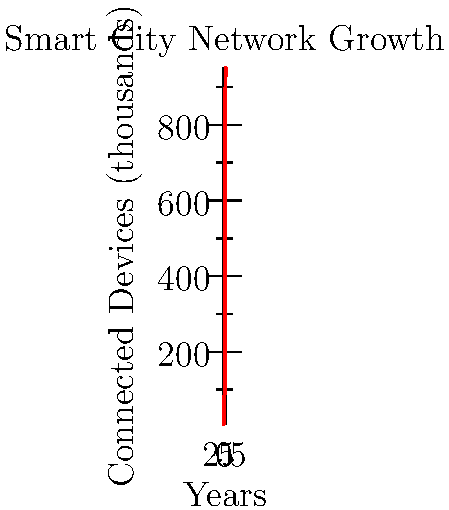In a smart city project, the number of connected devices is growing exponentially, as shown in the graph. If the current network infrastructure can support up to 500,000 devices, in which year will the system reach its capacity, assuming the trend continues? To solve this problem, we need to analyze the graph and identify when the number of connected devices exceeds 500,000 (or 500 thousand, as per the y-axis scale). Let's break it down step-by-step:

1. Observe the graph: It shows an exponential growth of connected devices over 5 years.
2. Analyze the data points:
   Year 0: ~10,000 devices
   Year 1: ~25,000 devices
   Year 2: ~60,000 devices
   Year 3: ~150,000 devices
   Year 4: ~380,000 devices
   Year 5: ~950,000 devices

3. Identify the threshold: We're looking for when the number exceeds 500,000 devices.

4. Locate the crossing point: Between Year 4 and Year 5, the number of devices crosses the 500,000 threshold.

5. Interpolate: Since the growth is exponential, the exact point will be closer to Year 4 than Year 5.

6. Conclusion: The system will reach its capacity during Year 4, as it's the last full year before exceeding the threshold.

This analysis shows that the infrastructure team needs to plan for a significant upgrade or expansion of the network capacity before the end of Year 4 to accommodate the rapidly growing number of devices in the smart city project.
Answer: Year 4 